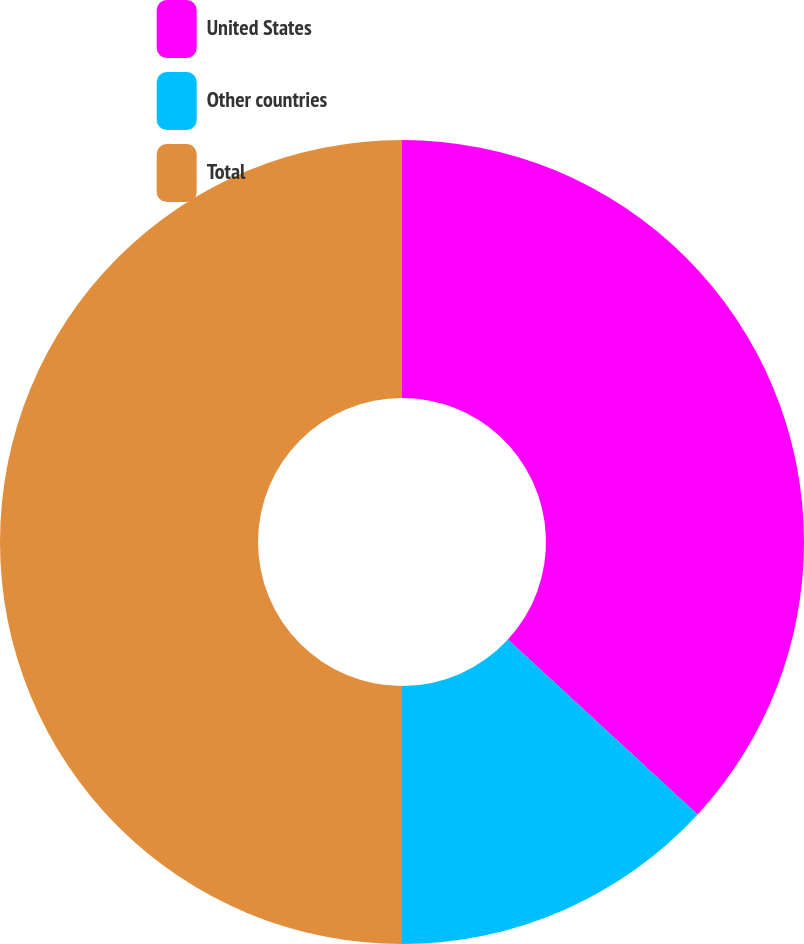Convert chart. <chart><loc_0><loc_0><loc_500><loc_500><pie_chart><fcel>United States<fcel>Other countries<fcel>Total<nl><fcel>36.85%<fcel>13.15%<fcel>50.0%<nl></chart> 